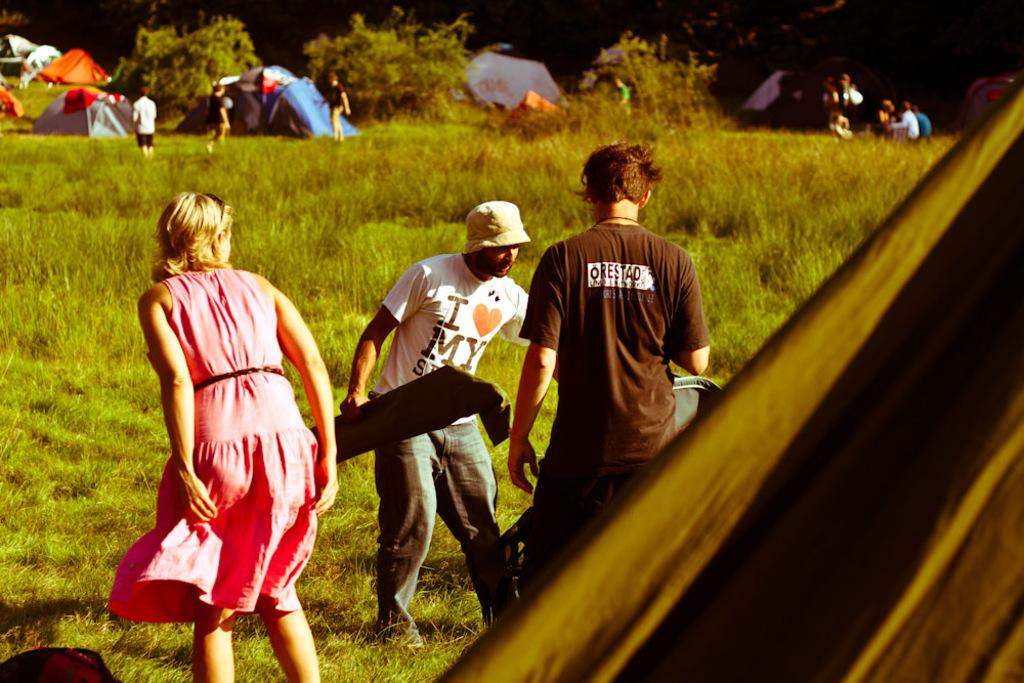What type of vegetation is present in the image? There is green grass and plants in the image. Who or what can be seen in the image besides the vegetation? There are people in the image. What can be seen in the background of the image? There are colorful tents in the background of the image. How would you describe the lighting in the image? The background of the image is dark. What type of cherry is being used to polish the leaves in the image? There is no cherry or polishing activity involving leaves present in the image. 